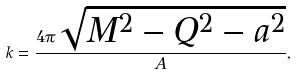<formula> <loc_0><loc_0><loc_500><loc_500>k = \frac { 4 \pi \sqrt { M ^ { 2 } - Q ^ { 2 } - a ^ { 2 } } } { A } ,</formula> 